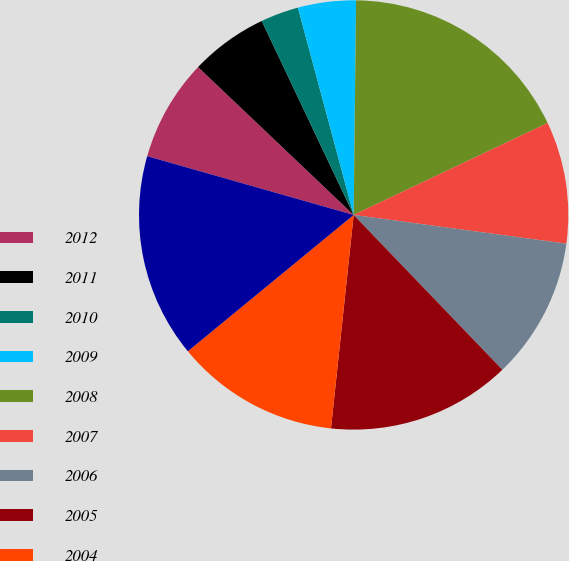<chart> <loc_0><loc_0><loc_500><loc_500><pie_chart><fcel>2012<fcel>2011<fcel>2010<fcel>2009<fcel>2008<fcel>2007<fcel>2006<fcel>2005<fcel>2004<fcel>2003<nl><fcel>7.68%<fcel>5.86%<fcel>2.86%<fcel>4.36%<fcel>17.77%<fcel>9.18%<fcel>10.68%<fcel>13.86%<fcel>12.36%<fcel>15.36%<nl></chart> 